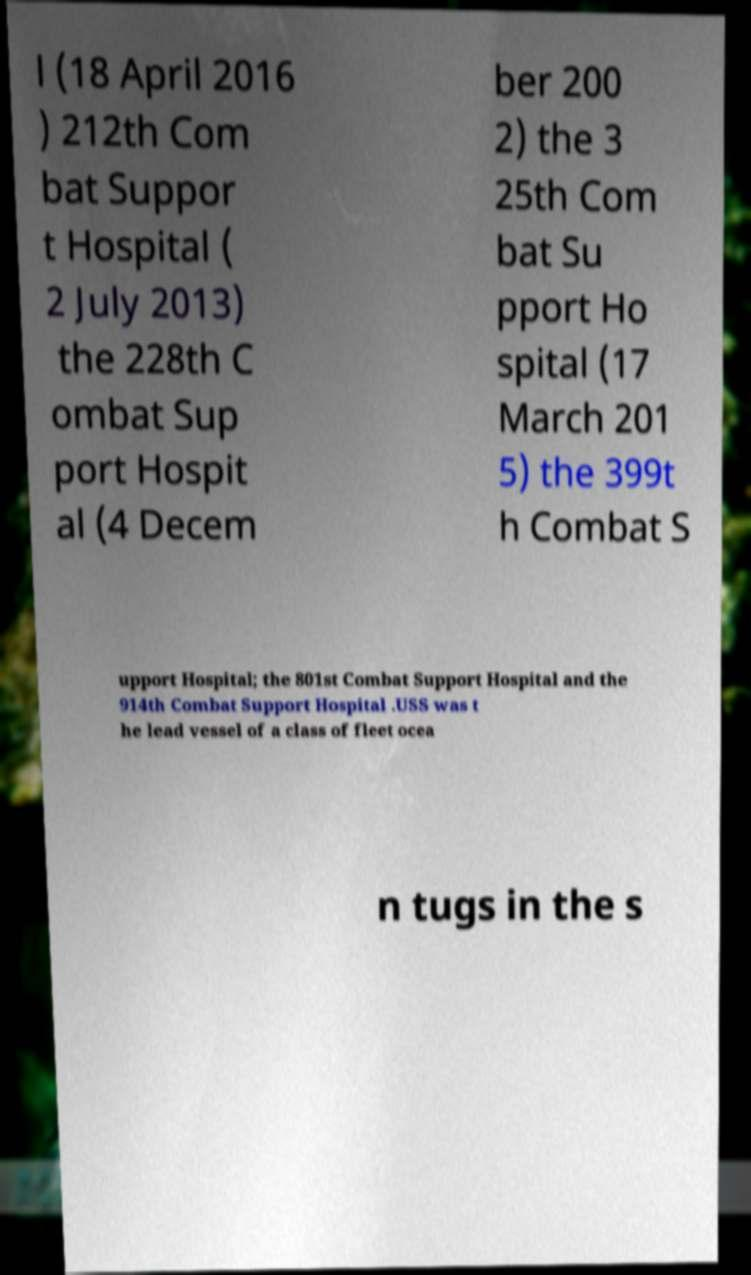Please read and relay the text visible in this image. What does it say? l (18 April 2016 ) 212th Com bat Suppor t Hospital ( 2 July 2013) the 228th C ombat Sup port Hospit al (4 Decem ber 200 2) the 3 25th Com bat Su pport Ho spital (17 March 201 5) the 399t h Combat S upport Hospital; the 801st Combat Support Hospital and the 914th Combat Support Hospital .USS was t he lead vessel of a class of fleet ocea n tugs in the s 